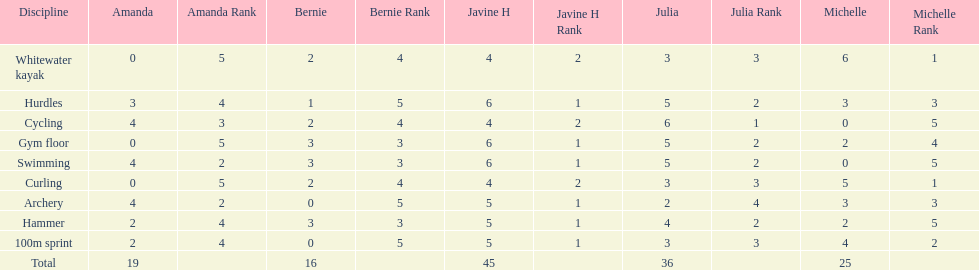What other girl besides amanda also had a 4 in cycling? Javine H. 